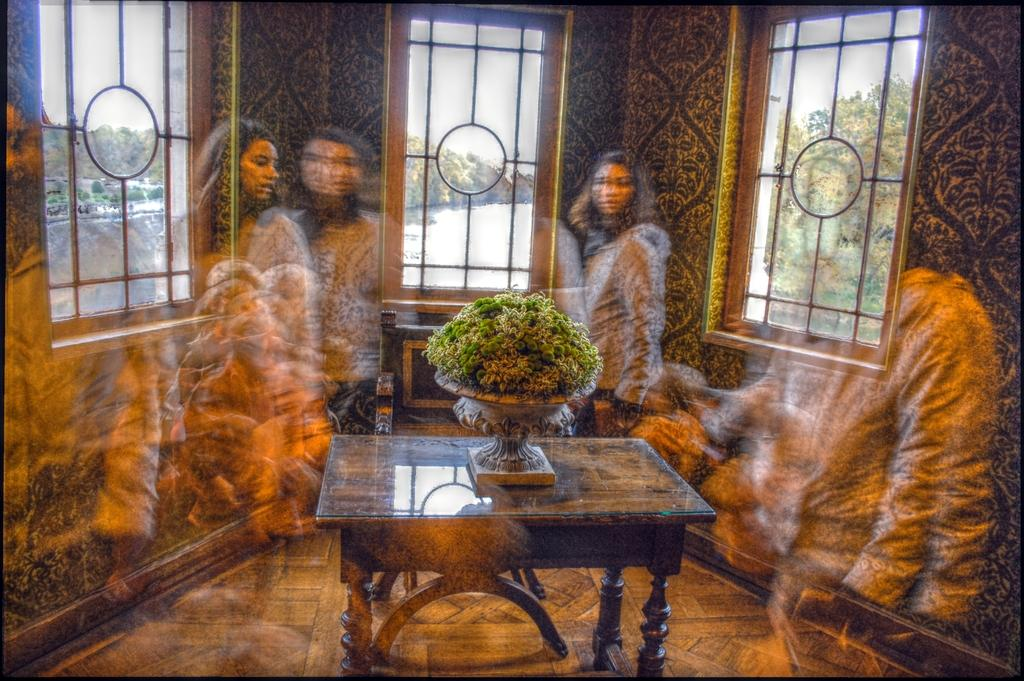Where is the image taken? The image is inside a room. What can be found on a table in the room? There is a plant on a table in the room. Who is present in the room? A woman is standing in the room. What is a source of natural light in the room? There is a window in the room. What can be seen outside the window? Trees are visible outside the window. What type of water body is present in the image? The image contains a freshwater river. Can you see a hose being used to water the plants in the image? There is no hose visible in the image. Is there a giraffe or bear present in the room? Neither a giraffe nor a bear is present in the image. 